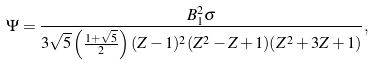Convert formula to latex. <formula><loc_0><loc_0><loc_500><loc_500>\Psi = \frac { B _ { 1 } ^ { 2 } \sigma } { 3 \sqrt { 5 } \left ( \frac { 1 + \sqrt { 5 } } { 2 } \right ) ( Z - 1 ) ^ { 2 } ( Z ^ { 2 } - Z + 1 ) ( Z ^ { 2 } + 3 Z + 1 ) } ,</formula> 